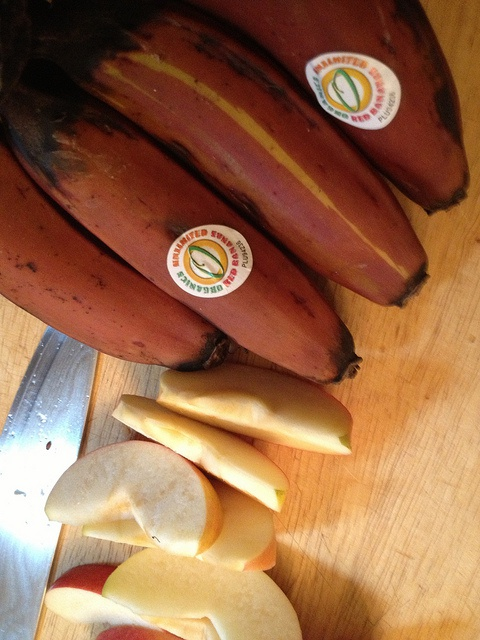Describe the objects in this image and their specific colors. I can see banana in black, maroon, and brown tones, dining table in black, tan, and brown tones, and knife in black, white, darkgray, and lightblue tones in this image. 